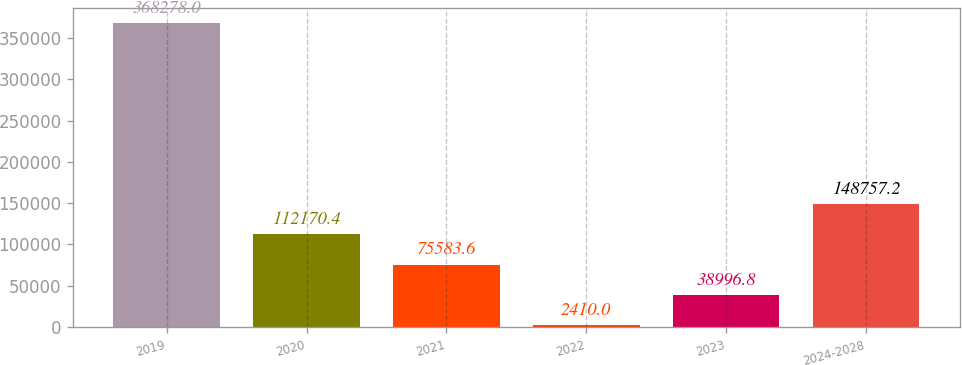<chart> <loc_0><loc_0><loc_500><loc_500><bar_chart><fcel>2019<fcel>2020<fcel>2021<fcel>2022<fcel>2023<fcel>2024-2028<nl><fcel>368278<fcel>112170<fcel>75583.6<fcel>2410<fcel>38996.8<fcel>148757<nl></chart> 